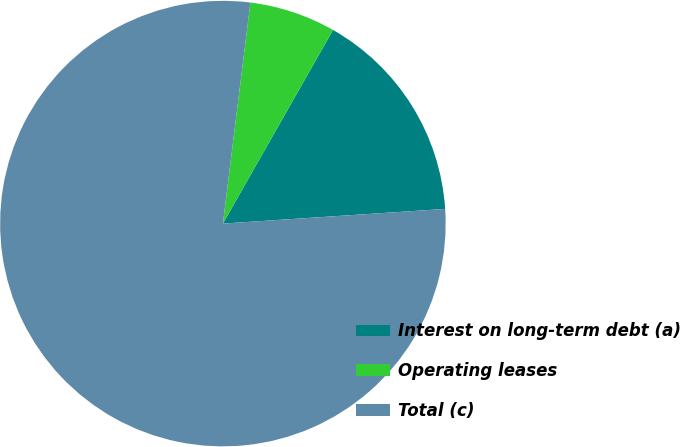Convert chart. <chart><loc_0><loc_0><loc_500><loc_500><pie_chart><fcel>Interest on long-term debt (a)<fcel>Operating leases<fcel>Total (c)<nl><fcel>15.72%<fcel>6.26%<fcel>78.02%<nl></chart> 